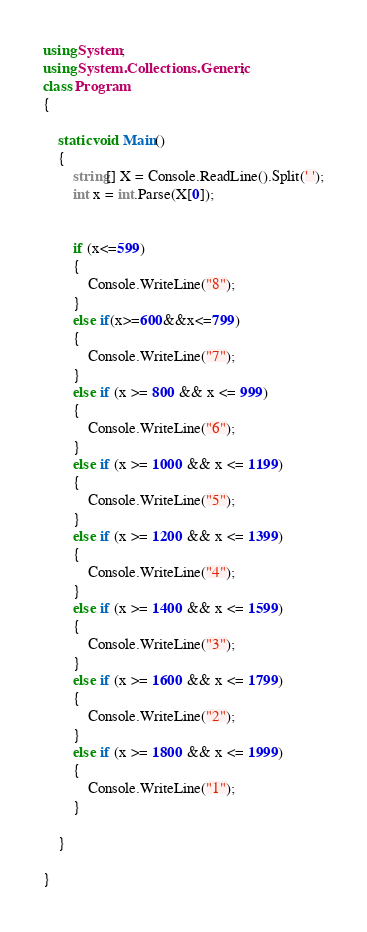<code> <loc_0><loc_0><loc_500><loc_500><_C#_>using System;
using System.Collections.Generic;
class Program
{

    static void Main()
    {
        string[] X = Console.ReadLine().Split(' ');
        int x = int.Parse(X[0]);
        

        if (x<=599)
        {
            Console.WriteLine("8");
        }
        else if(x>=600&&x<=799)
        {
            Console.WriteLine("7");
        }
        else if (x >= 800 && x <= 999)
        {
            Console.WriteLine("6");
        }
        else if (x >= 1000 && x <= 1199)
        {
            Console.WriteLine("5");
        }
        else if (x >= 1200 && x <= 1399)
        {
            Console.WriteLine("4");
        }
        else if (x >= 1400 && x <= 1599)
        {
            Console.WriteLine("3");
        }
        else if (x >= 1600 && x <= 1799)
        {
            Console.WriteLine("2");
        }
        else if (x >= 1800 && x <= 1999)
        {
            Console.WriteLine("1");
        }

    }

}

</code> 